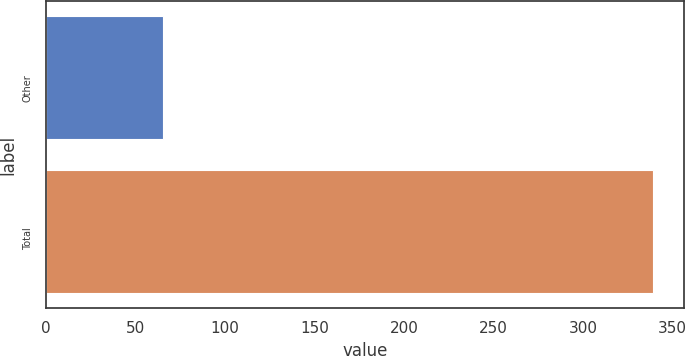<chart> <loc_0><loc_0><loc_500><loc_500><bar_chart><fcel>Other<fcel>Total<nl><fcel>65.2<fcel>339.2<nl></chart> 